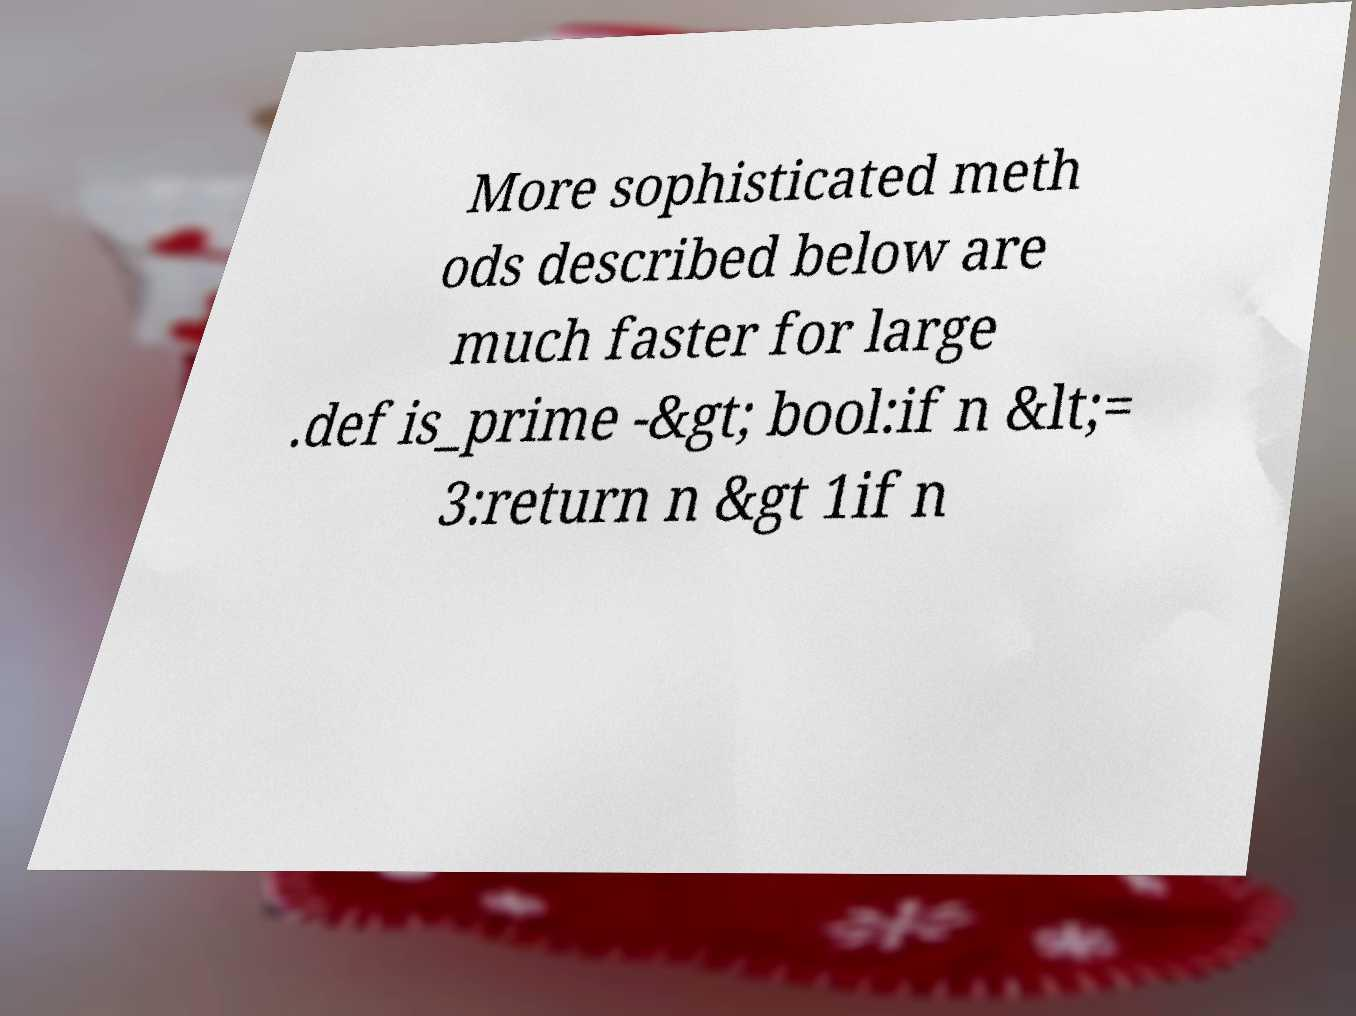For documentation purposes, I need the text within this image transcribed. Could you provide that? More sophisticated meth ods described below are much faster for large .def is_prime -&gt; bool:if n &lt;= 3:return n &gt 1if n 